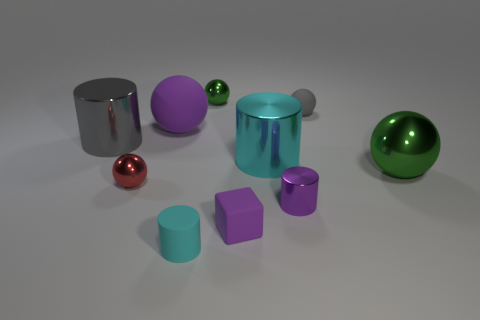What shape is the purple object that is made of the same material as the big gray cylinder?
Offer a terse response. Cylinder. Are there any metallic objects that have the same color as the big matte thing?
Your response must be concise. Yes. What is the material of the big green object?
Provide a succinct answer. Metal. What number of things are either metallic objects or metallic cylinders?
Make the answer very short. 6. There is a rubber thing that is to the left of the cyan rubber thing; what is its size?
Give a very brief answer. Large. How many other objects are there of the same material as the large green thing?
Provide a succinct answer. 5. There is a tiny sphere to the right of the tiny shiny cylinder; are there any small red objects that are behind it?
Ensure brevity in your answer.  No. Is there anything else that is the same shape as the red metal object?
Ensure brevity in your answer.  Yes. What color is the big shiny thing that is the same shape as the tiny gray matte thing?
Offer a very short reply. Green. What is the size of the matte cylinder?
Offer a very short reply. Small. 